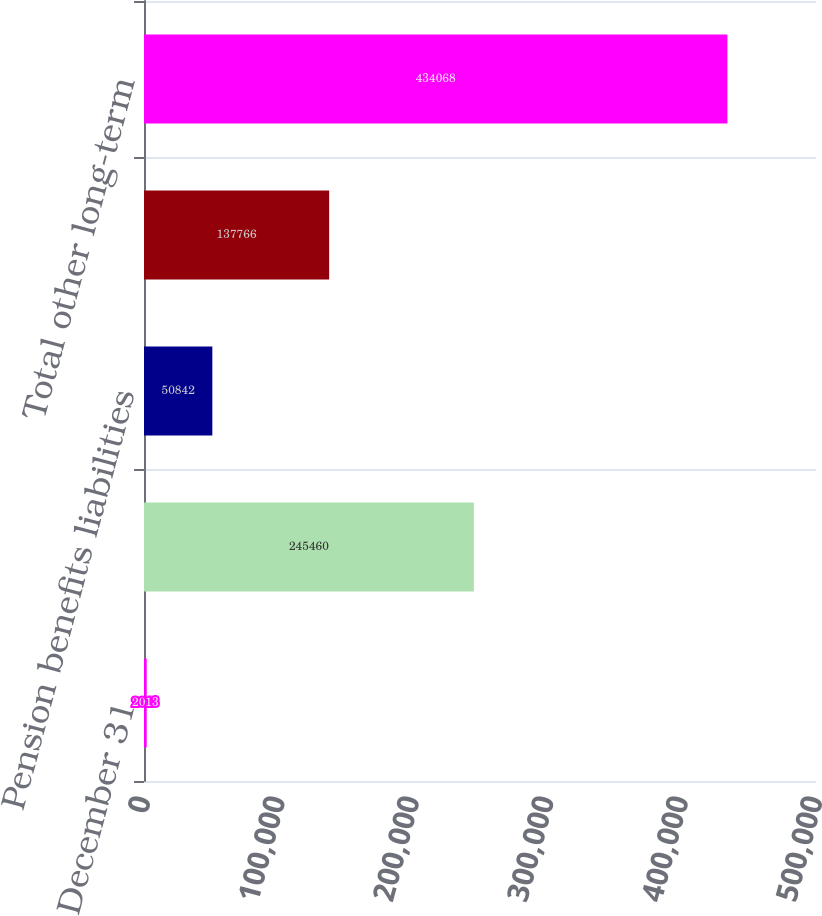Convert chart to OTSL. <chart><loc_0><loc_0><loc_500><loc_500><bar_chart><fcel>December 31<fcel>Post-retirement benefits<fcel>Pension benefits liabilities<fcel>Other<fcel>Total other long-term<nl><fcel>2013<fcel>245460<fcel>50842<fcel>137766<fcel>434068<nl></chart> 